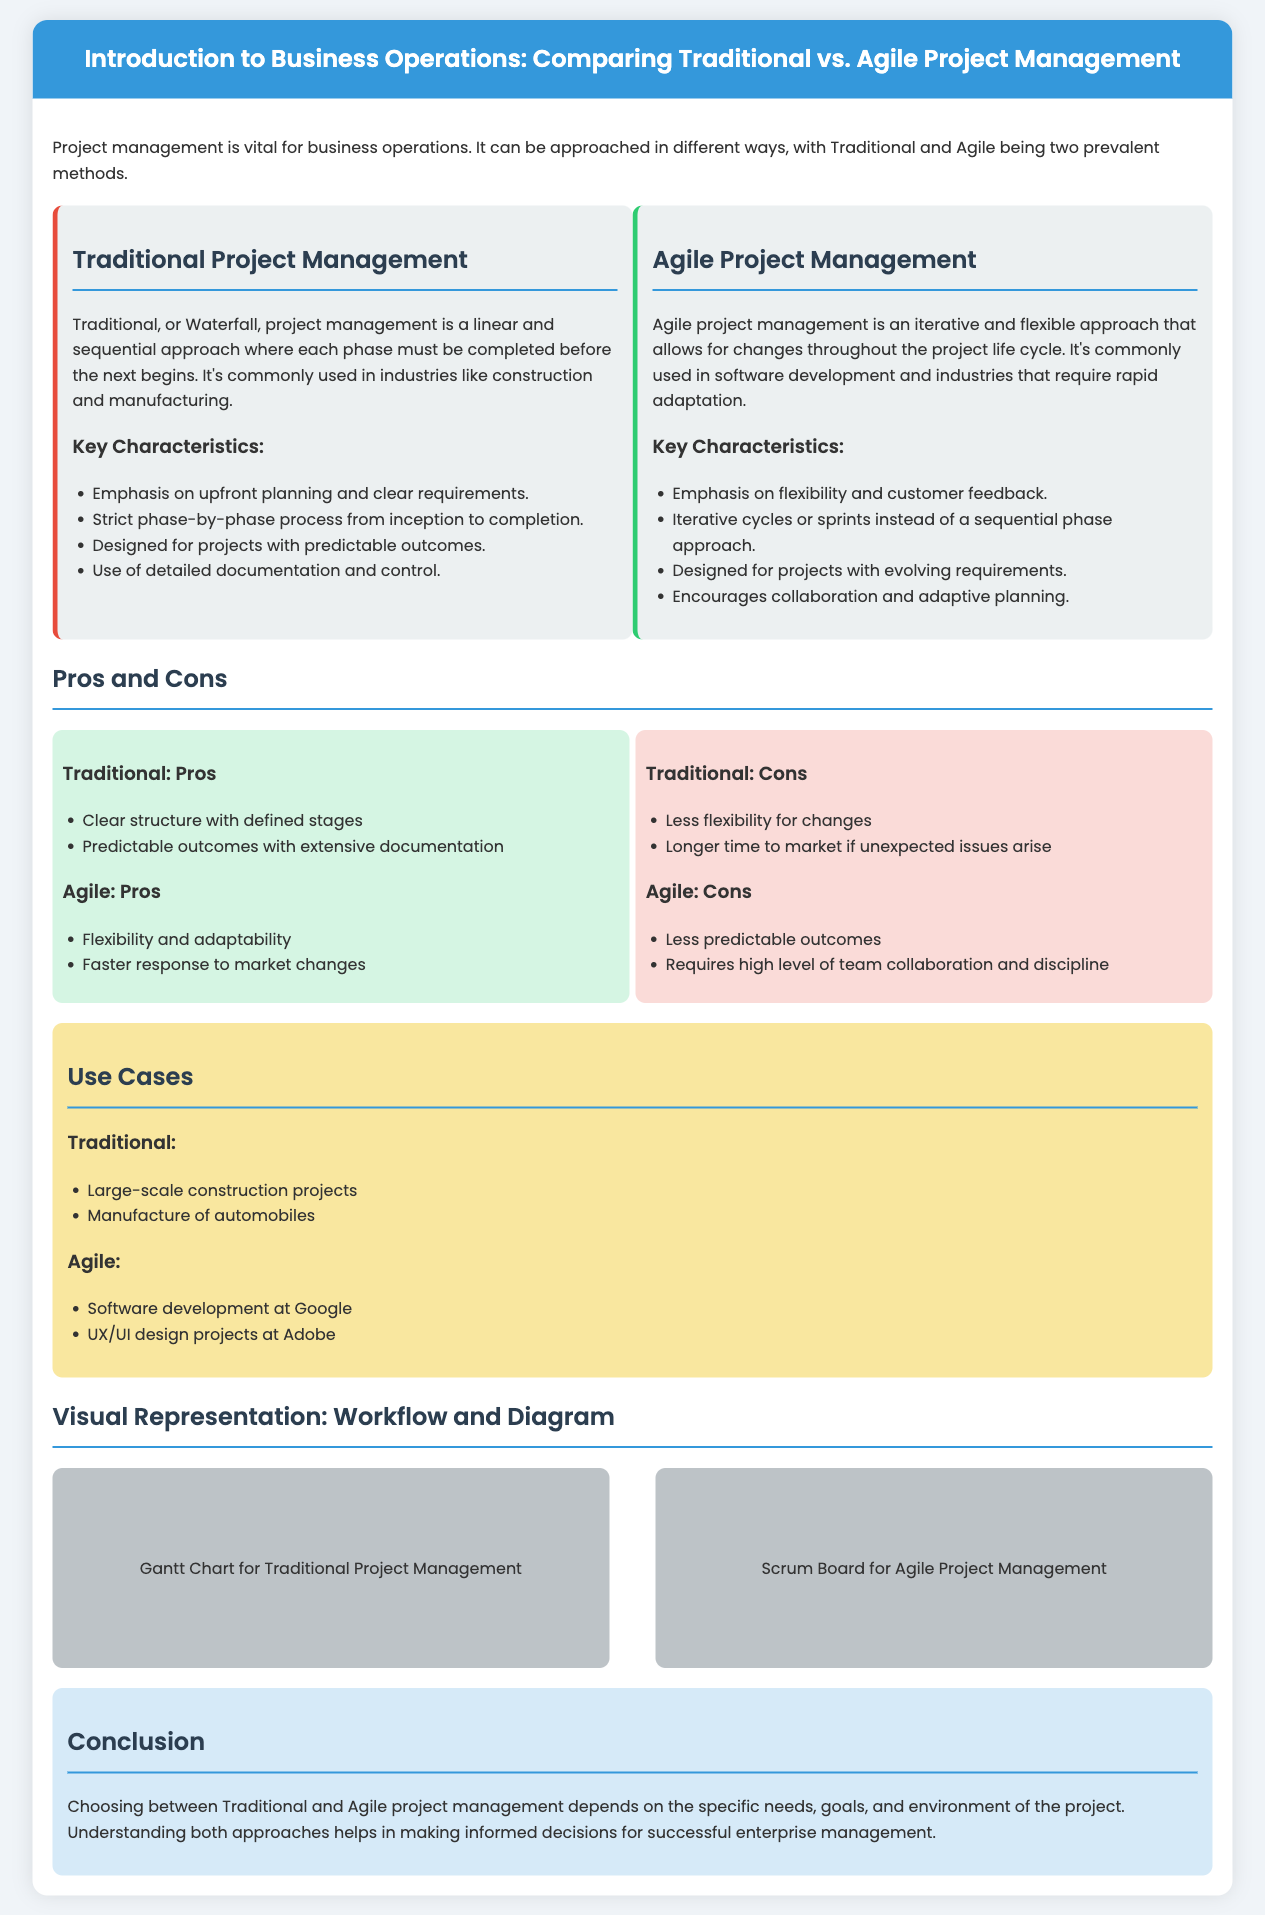what is the main focus of Traditional Project Management? The main focus is on a linear and sequential approach where each phase must be completed before the next begins.
Answer: linear and sequential approach what industries commonly use Traditional Project Management? Traditional Project Management is commonly used in industries like construction and manufacturing.
Answer: construction and manufacturing what are the pros of Agile Project Management? The pros include flexibility and adaptability, and faster response to market changes.
Answer: flexibility and adaptability name one use case for Agile Project Management. Agile Project Management is used in software development at Google.
Answer: software development at Google what is the primary characteristic of Agile Project Management? The primary characteristic is an iterative and flexible approach that allows for changes throughout the project life cycle.
Answer: iterative and flexible approach what is a Gantt Chart used for? A Gantt Chart is used for Traditional Project Management to represent planning over time.
Answer: planning over time what are the cons of Traditional Project Management? The cons include less flexibility for changes, and longer time to market if unexpected issues arise.
Answer: less flexibility for changes how does Agile Project Management handle project requirements? Agile handles project requirements as evolving, allowing for customer feedback and continuous improvements.
Answer: evolving what is emphasized in Traditional Project Management? Traditional Project Management emphasizes upfront planning and clear requirements.
Answer: upfront planning and clear requirements which project management approach encourages collaboration? Agile Project Management encourages collaboration among team members.
Answer: Agile Project Management 